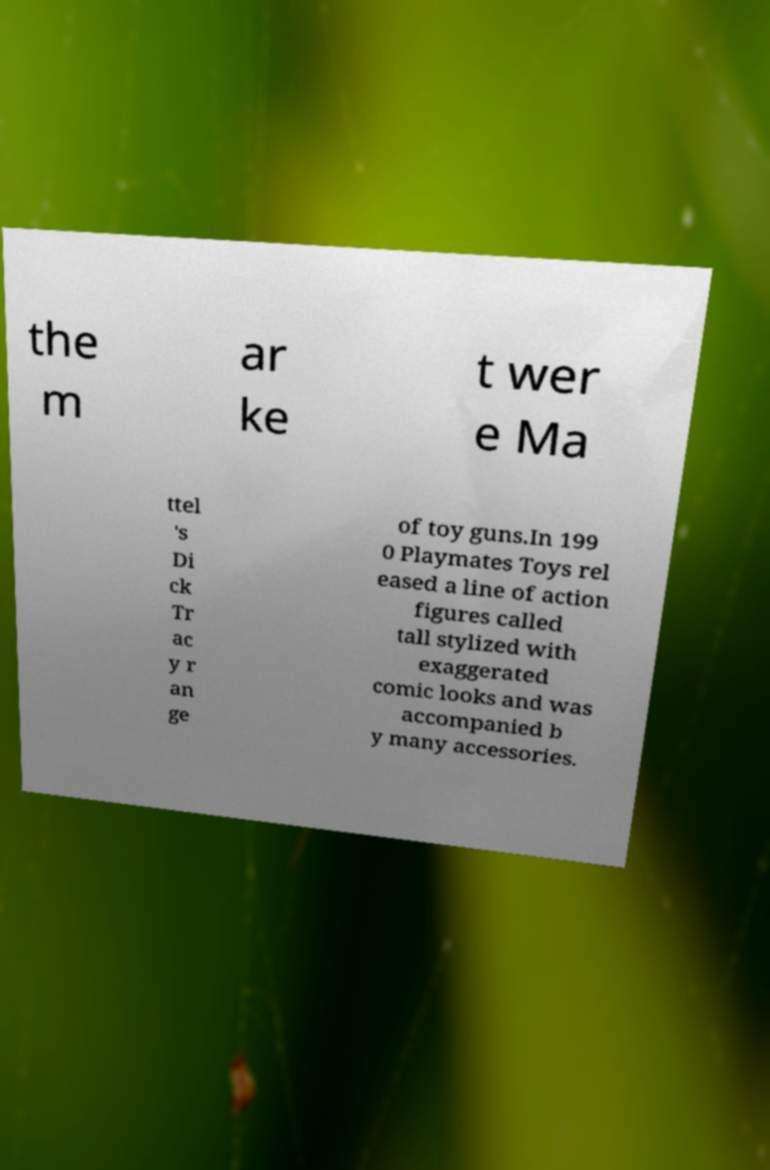For documentation purposes, I need the text within this image transcribed. Could you provide that? the m ar ke t wer e Ma ttel 's Di ck Tr ac y r an ge of toy guns.In 199 0 Playmates Toys rel eased a line of action figures called tall stylized with exaggerated comic looks and was accompanied b y many accessories. 